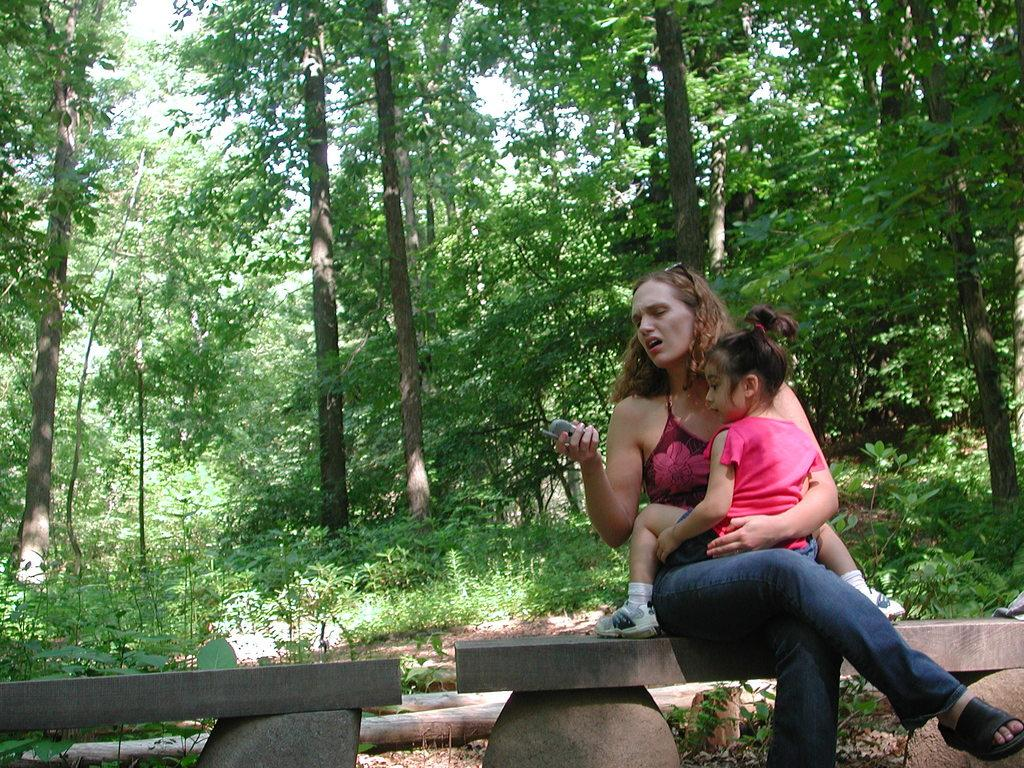What is the woman doing in the image? The woman is sitting on a bench in the image. Is there anyone else with the woman in the image? Yes, the woman is holding a baby on her lap. What is the woman holding in her hand? The woman is holding a phone in her hand. What can be seen in the background behind the bench? There are trees visible behind the bench. What type of respect can be seen being given to the baby in the image? There is no indication of respect being given to the baby in the image; the woman is simply holding the baby on her lap. 